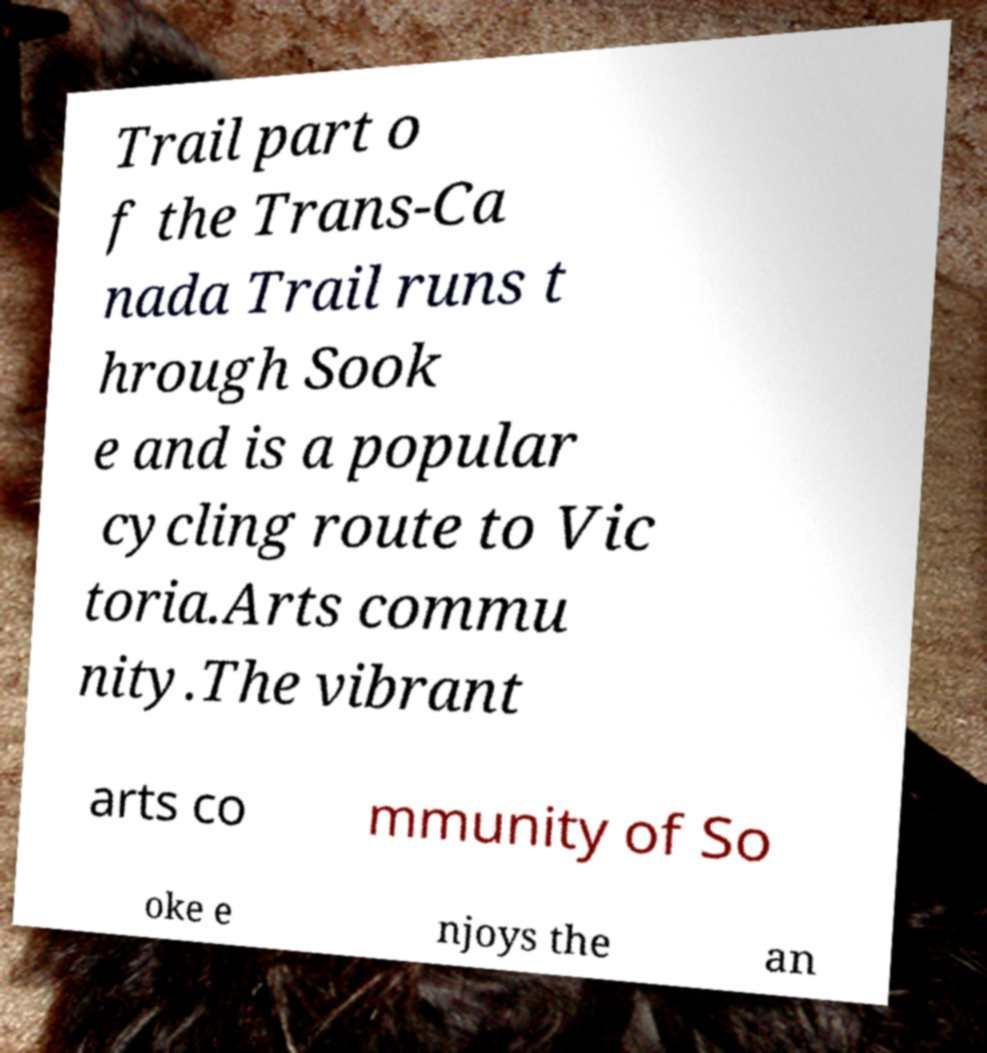Can you read and provide the text displayed in the image?This photo seems to have some interesting text. Can you extract and type it out for me? Trail part o f the Trans-Ca nada Trail runs t hrough Sook e and is a popular cycling route to Vic toria.Arts commu nity.The vibrant arts co mmunity of So oke e njoys the an 